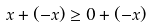Convert formula to latex. <formula><loc_0><loc_0><loc_500><loc_500>x + ( - x ) \geq 0 + ( - x )</formula> 